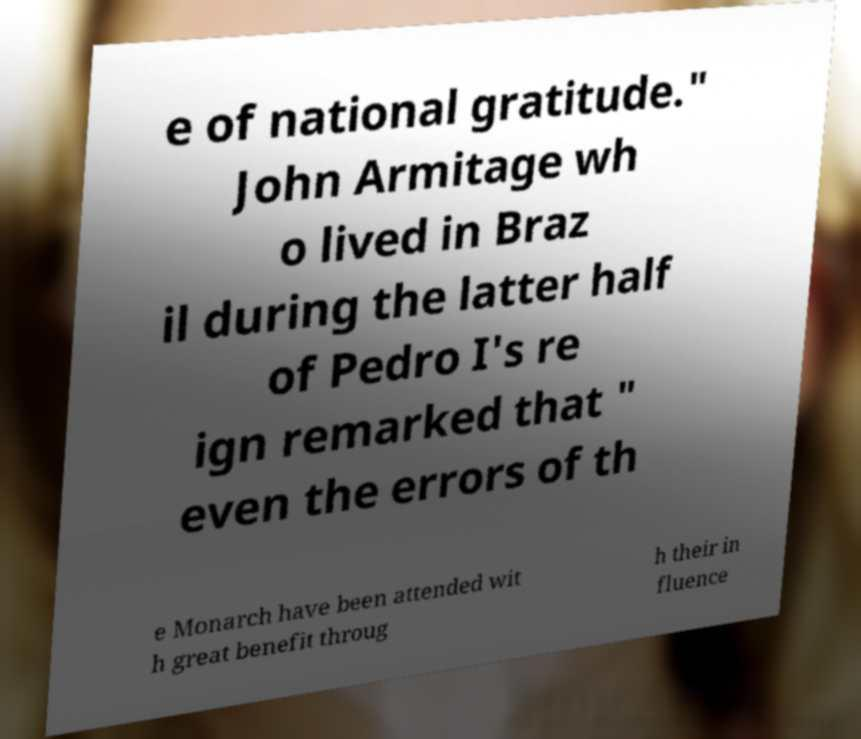Please identify and transcribe the text found in this image. e of national gratitude." John Armitage wh o lived in Braz il during the latter half of Pedro I's re ign remarked that " even the errors of th e Monarch have been attended wit h great benefit throug h their in fluence 